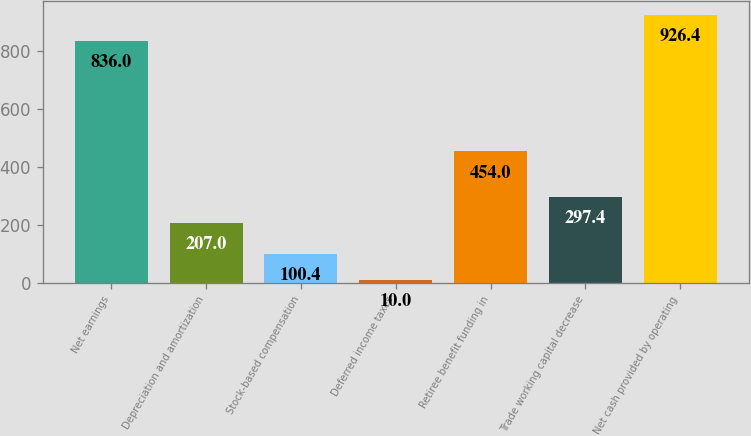<chart> <loc_0><loc_0><loc_500><loc_500><bar_chart><fcel>Net earnings<fcel>Depreciation and amortization<fcel>Stock-based compensation<fcel>Deferred income taxes<fcel>Retiree benefit funding in<fcel>Trade working capital decrease<fcel>Net cash provided by operating<nl><fcel>836<fcel>207<fcel>100.4<fcel>10<fcel>454<fcel>297.4<fcel>926.4<nl></chart> 